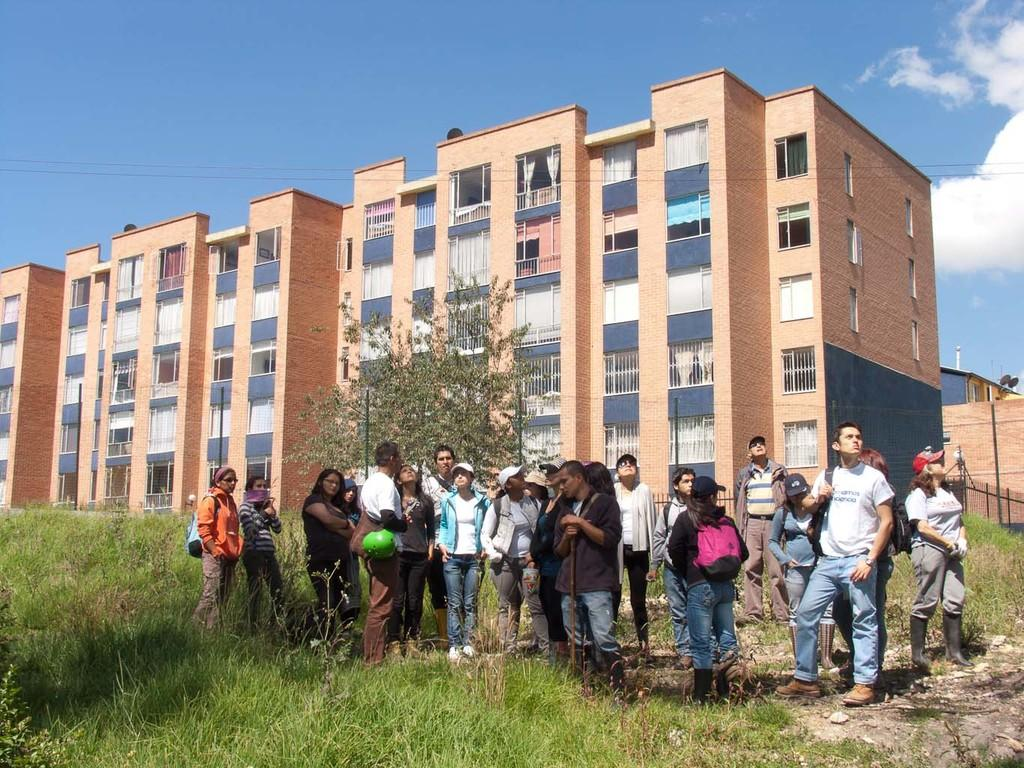What are the people in the image doing? The people in the image are standing on the grass. What can be seen in the background of the image? There is a building and a tree in the background of the image. What is visible at the top of the image? The sky is visible at the top of the image. What can be observed in the sky? There are clouds in the sky. What type of history lesson is being taught in the image? There is no indication of a history lesson or any teaching activity in the image. Can you see any chess pieces on the grass in the image? There are no chess pieces visible in the image. 